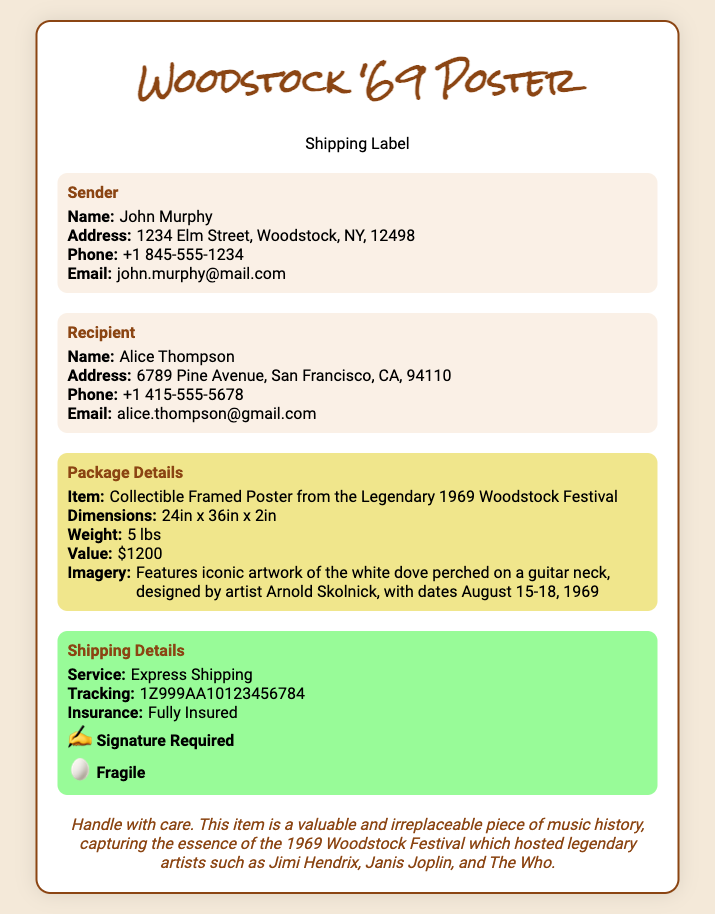What is the sender's name? The sender's name is explicitly mentioned in the "Sender" section of the document.
Answer: John Murphy What is the recipient's address? The recipient's address is provided in the "Recipient" section, detailing the complete address.
Answer: 6789 Pine Avenue, San Francisco, CA, 94110 What is the weight of the poster? The "Package Details" section states the weight of the item.
Answer: 5 lbs What is the value of the collectible? The value is specified in the "Package Details" section of the document.
Answer: $1200 What is the tracking number? The tracking number is mentioned in the "Shipping Details" section.
Answer: 1Z999AA10123456784 Who designed the artwork for the poster? The artwork designer is mentioned in the "Package Details" section of the document.
Answer: Arnold Skolnick What dates are featured on the poster? The featured dates are noted in the description of the imagery in the "Package Details" section.
Answer: August 15-18, 1969 Which shipping service is used? The shipping service type is provided in the "Shipping Details" section.
Answer: Express Shipping Is the item fragile? The "Shipping Details" section indicates if the item is fragile.
Answer: Yes 